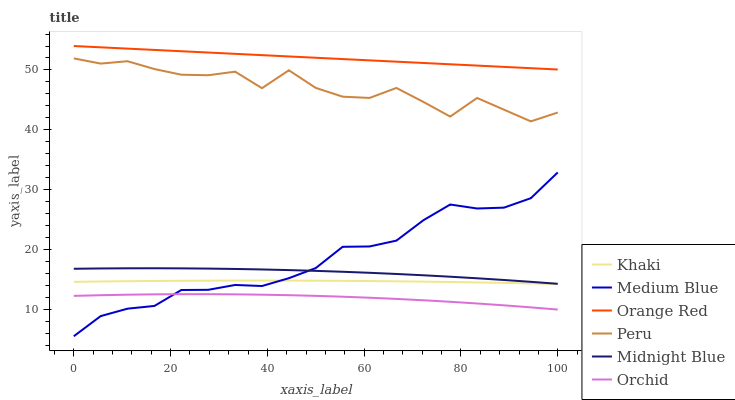Does Orchid have the minimum area under the curve?
Answer yes or no. Yes. Does Orange Red have the maximum area under the curve?
Answer yes or no. Yes. Does Midnight Blue have the minimum area under the curve?
Answer yes or no. No. Does Midnight Blue have the maximum area under the curve?
Answer yes or no. No. Is Orange Red the smoothest?
Answer yes or no. Yes. Is Peru the roughest?
Answer yes or no. Yes. Is Midnight Blue the smoothest?
Answer yes or no. No. Is Midnight Blue the roughest?
Answer yes or no. No. Does Medium Blue have the lowest value?
Answer yes or no. Yes. Does Midnight Blue have the lowest value?
Answer yes or no. No. Does Orange Red have the highest value?
Answer yes or no. Yes. Does Midnight Blue have the highest value?
Answer yes or no. No. Is Khaki less than Orange Red?
Answer yes or no. Yes. Is Peru greater than Midnight Blue?
Answer yes or no. Yes. Does Khaki intersect Medium Blue?
Answer yes or no. Yes. Is Khaki less than Medium Blue?
Answer yes or no. No. Is Khaki greater than Medium Blue?
Answer yes or no. No. Does Khaki intersect Orange Red?
Answer yes or no. No. 